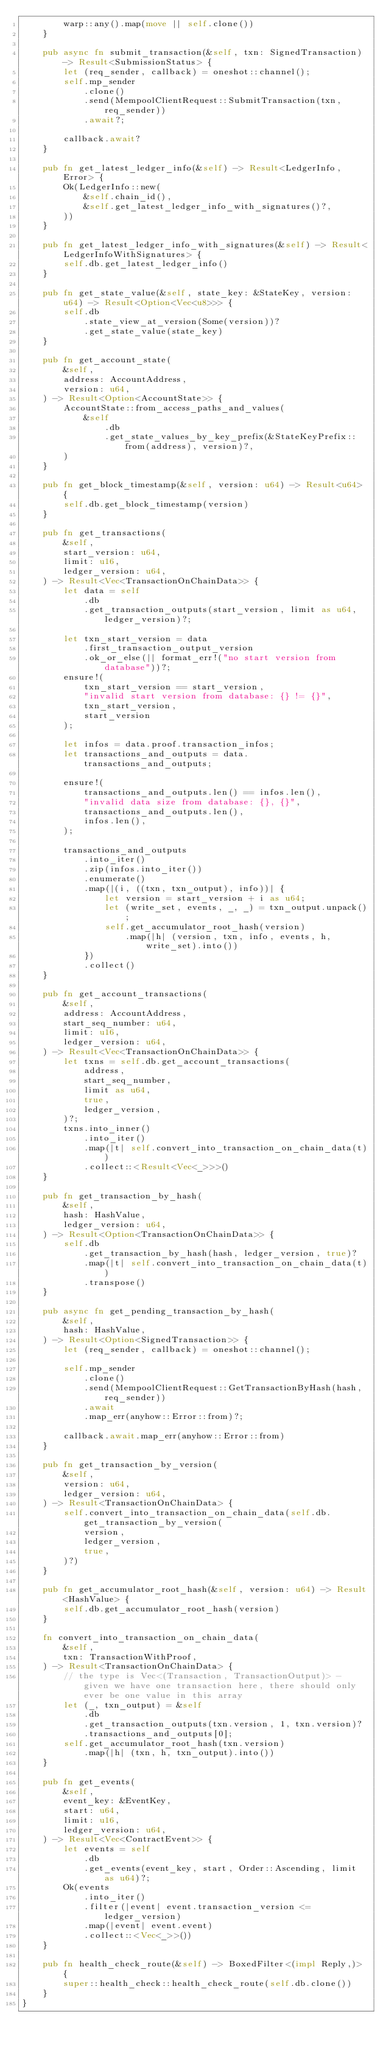<code> <loc_0><loc_0><loc_500><loc_500><_Rust_>        warp::any().map(move || self.clone())
    }

    pub async fn submit_transaction(&self, txn: SignedTransaction) -> Result<SubmissionStatus> {
        let (req_sender, callback) = oneshot::channel();
        self.mp_sender
            .clone()
            .send(MempoolClientRequest::SubmitTransaction(txn, req_sender))
            .await?;

        callback.await?
    }

    pub fn get_latest_ledger_info(&self) -> Result<LedgerInfo, Error> {
        Ok(LedgerInfo::new(
            &self.chain_id(),
            &self.get_latest_ledger_info_with_signatures()?,
        ))
    }

    pub fn get_latest_ledger_info_with_signatures(&self) -> Result<LedgerInfoWithSignatures> {
        self.db.get_latest_ledger_info()
    }

    pub fn get_state_value(&self, state_key: &StateKey, version: u64) -> Result<Option<Vec<u8>>> {
        self.db
            .state_view_at_version(Some(version))?
            .get_state_value(state_key)
    }

    pub fn get_account_state(
        &self,
        address: AccountAddress,
        version: u64,
    ) -> Result<Option<AccountState>> {
        AccountState::from_access_paths_and_values(
            &self
                .db
                .get_state_values_by_key_prefix(&StateKeyPrefix::from(address), version)?,
        )
    }

    pub fn get_block_timestamp(&self, version: u64) -> Result<u64> {
        self.db.get_block_timestamp(version)
    }

    pub fn get_transactions(
        &self,
        start_version: u64,
        limit: u16,
        ledger_version: u64,
    ) -> Result<Vec<TransactionOnChainData>> {
        let data = self
            .db
            .get_transaction_outputs(start_version, limit as u64, ledger_version)?;

        let txn_start_version = data
            .first_transaction_output_version
            .ok_or_else(|| format_err!("no start version from database"))?;
        ensure!(
            txn_start_version == start_version,
            "invalid start version from database: {} != {}",
            txn_start_version,
            start_version
        );

        let infos = data.proof.transaction_infos;
        let transactions_and_outputs = data.transactions_and_outputs;

        ensure!(
            transactions_and_outputs.len() == infos.len(),
            "invalid data size from database: {}, {}",
            transactions_and_outputs.len(),
            infos.len(),
        );

        transactions_and_outputs
            .into_iter()
            .zip(infos.into_iter())
            .enumerate()
            .map(|(i, ((txn, txn_output), info))| {
                let version = start_version + i as u64;
                let (write_set, events, _, _) = txn_output.unpack();
                self.get_accumulator_root_hash(version)
                    .map(|h| (version, txn, info, events, h, write_set).into())
            })
            .collect()
    }

    pub fn get_account_transactions(
        &self,
        address: AccountAddress,
        start_seq_number: u64,
        limit: u16,
        ledger_version: u64,
    ) -> Result<Vec<TransactionOnChainData>> {
        let txns = self.db.get_account_transactions(
            address,
            start_seq_number,
            limit as u64,
            true,
            ledger_version,
        )?;
        txns.into_inner()
            .into_iter()
            .map(|t| self.convert_into_transaction_on_chain_data(t))
            .collect::<Result<Vec<_>>>()
    }

    pub fn get_transaction_by_hash(
        &self,
        hash: HashValue,
        ledger_version: u64,
    ) -> Result<Option<TransactionOnChainData>> {
        self.db
            .get_transaction_by_hash(hash, ledger_version, true)?
            .map(|t| self.convert_into_transaction_on_chain_data(t))
            .transpose()
    }

    pub async fn get_pending_transaction_by_hash(
        &self,
        hash: HashValue,
    ) -> Result<Option<SignedTransaction>> {
        let (req_sender, callback) = oneshot::channel();

        self.mp_sender
            .clone()
            .send(MempoolClientRequest::GetTransactionByHash(hash, req_sender))
            .await
            .map_err(anyhow::Error::from)?;

        callback.await.map_err(anyhow::Error::from)
    }

    pub fn get_transaction_by_version(
        &self,
        version: u64,
        ledger_version: u64,
    ) -> Result<TransactionOnChainData> {
        self.convert_into_transaction_on_chain_data(self.db.get_transaction_by_version(
            version,
            ledger_version,
            true,
        )?)
    }

    pub fn get_accumulator_root_hash(&self, version: u64) -> Result<HashValue> {
        self.db.get_accumulator_root_hash(version)
    }

    fn convert_into_transaction_on_chain_data(
        &self,
        txn: TransactionWithProof,
    ) -> Result<TransactionOnChainData> {
        // the type is Vec<(Transaction, TransactionOutput)> - given we have one transaction here, there should only ever be one value in this array
        let (_, txn_output) = &self
            .db
            .get_transaction_outputs(txn.version, 1, txn.version)?
            .transactions_and_outputs[0];
        self.get_accumulator_root_hash(txn.version)
            .map(|h| (txn, h, txn_output).into())
    }

    pub fn get_events(
        &self,
        event_key: &EventKey,
        start: u64,
        limit: u16,
        ledger_version: u64,
    ) -> Result<Vec<ContractEvent>> {
        let events = self
            .db
            .get_events(event_key, start, Order::Ascending, limit as u64)?;
        Ok(events
            .into_iter()
            .filter(|event| event.transaction_version <= ledger_version)
            .map(|event| event.event)
            .collect::<Vec<_>>())
    }

    pub fn health_check_route(&self) -> BoxedFilter<(impl Reply,)> {
        super::health_check::health_check_route(self.db.clone())
    }
}
</code> 